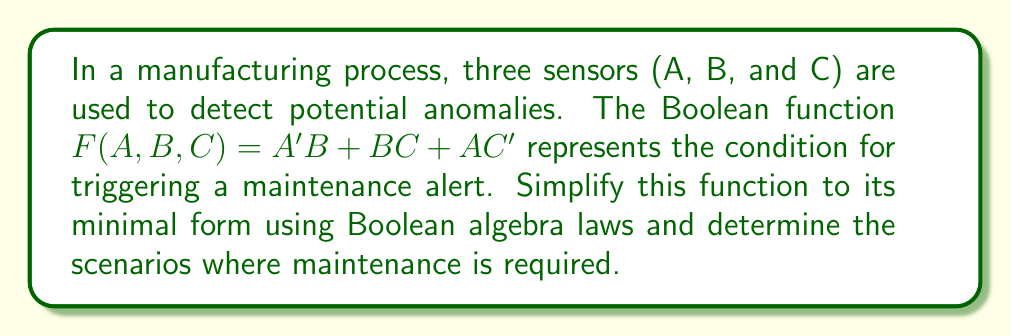What is the answer to this math problem? Let's simplify the Boolean function $F(A,B,C) = A'B + BC + AC'$ step by step:

1) First, let's apply the distributive law to the term $BC$:
   $F(A,B,C) = A'B + BC + AC'$
   $= A'B + ABC + A'BC + AC'$

2) Now we can combine $A'B$ and $A'BC$:
   $= A'B(1 + C) + ABC + AC'$
   $= A'B + ABC + AC'$

3) Apply the absorption law to $A'B$ and $ABC$:
   $= A'B + AC'$

4) This is the minimal form of the function. We can verify it using a Karnaugh map or by checking that no further simplification is possible.

5) To determine the scenarios where maintenance is required, we need to find the cases where $F(A,B,C) = 1$:
   - When $A = 0$ and $B = 1$, regardless of C ($A'B$ term)
   - When $A = 1$ and $C = 0$ ($AC'$ term)

Therefore, maintenance is required in the following cases:
- Sensor A is OFF (0) and sensor B is ON (1)
- Sensor A is ON (1) and sensor C is OFF (0)
Answer: $F(A,B,C) = A'B + AC'$ 